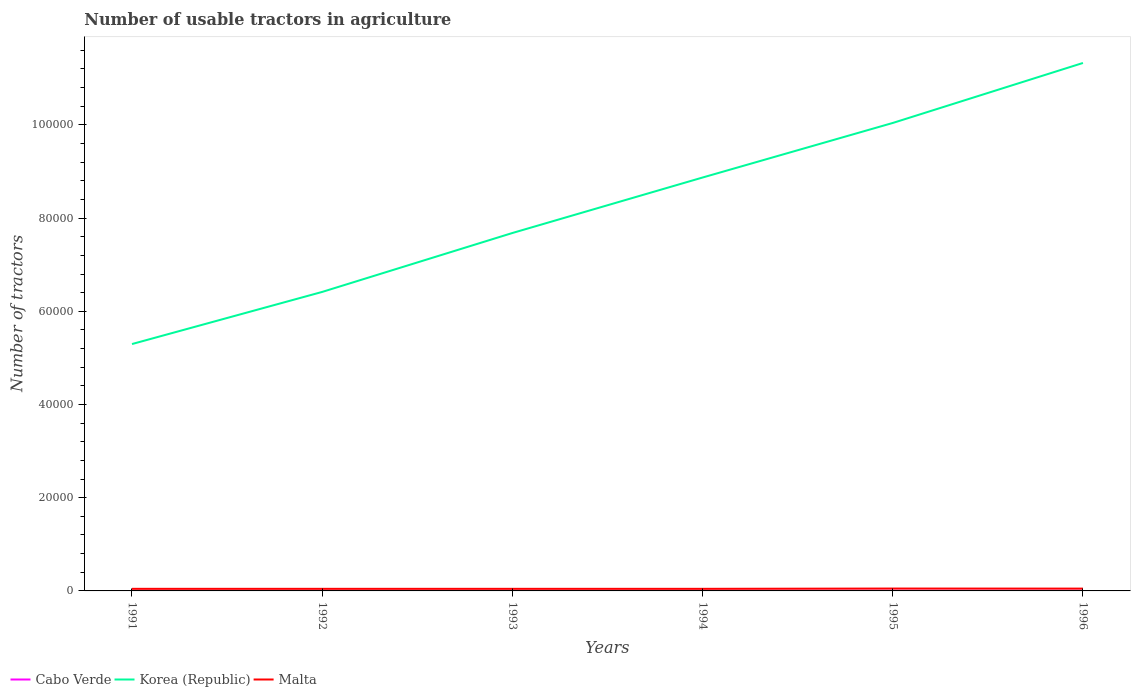How many different coloured lines are there?
Ensure brevity in your answer.  3. Does the line corresponding to Cabo Verde intersect with the line corresponding to Malta?
Provide a succinct answer. No. Across all years, what is the maximum number of usable tractors in agriculture in Korea (Republic)?
Offer a very short reply. 5.30e+04. In which year was the number of usable tractors in agriculture in Malta maximum?
Provide a succinct answer. 1991. What is the total number of usable tractors in agriculture in Korea (Republic) in the graph?
Ensure brevity in your answer.  -2.36e+04. What is the difference between the highest and the second highest number of usable tractors in agriculture in Korea (Republic)?
Offer a terse response. 6.03e+04. What is the difference between the highest and the lowest number of usable tractors in agriculture in Korea (Republic)?
Keep it short and to the point. 3. How many years are there in the graph?
Offer a terse response. 6. Are the values on the major ticks of Y-axis written in scientific E-notation?
Provide a short and direct response. No. Where does the legend appear in the graph?
Provide a succinct answer. Bottom left. What is the title of the graph?
Your response must be concise. Number of usable tractors in agriculture. Does "New Caledonia" appear as one of the legend labels in the graph?
Keep it short and to the point. No. What is the label or title of the X-axis?
Make the answer very short. Years. What is the label or title of the Y-axis?
Offer a terse response. Number of tractors. What is the Number of tractors of Korea (Republic) in 1991?
Offer a very short reply. 5.30e+04. What is the Number of tractors of Malta in 1991?
Give a very brief answer. 449. What is the Number of tractors in Korea (Republic) in 1992?
Offer a very short reply. 6.42e+04. What is the Number of tractors of Malta in 1992?
Your answer should be compact. 450. What is the Number of tractors in Korea (Republic) in 1993?
Provide a short and direct response. 7.68e+04. What is the Number of tractors of Malta in 1993?
Your answer should be compact. 450. What is the Number of tractors of Korea (Republic) in 1994?
Offer a very short reply. 8.87e+04. What is the Number of tractors in Malta in 1994?
Offer a terse response. 450. What is the Number of tractors in Korea (Republic) in 1995?
Provide a succinct answer. 1.00e+05. What is the Number of tractors of Malta in 1995?
Your answer should be very brief. 510. What is the Number of tractors of Cabo Verde in 1996?
Give a very brief answer. 41. What is the Number of tractors of Korea (Republic) in 1996?
Provide a short and direct response. 1.13e+05. What is the Number of tractors of Malta in 1996?
Offer a very short reply. 496. Across all years, what is the maximum Number of tractors of Korea (Republic)?
Provide a succinct answer. 1.13e+05. Across all years, what is the maximum Number of tractors of Malta?
Ensure brevity in your answer.  510. Across all years, what is the minimum Number of tractors in Korea (Republic)?
Give a very brief answer. 5.30e+04. Across all years, what is the minimum Number of tractors in Malta?
Your response must be concise. 449. What is the total Number of tractors in Cabo Verde in the graph?
Give a very brief answer. 216. What is the total Number of tractors in Korea (Republic) in the graph?
Offer a very short reply. 4.96e+05. What is the total Number of tractors in Malta in the graph?
Provide a short and direct response. 2805. What is the difference between the Number of tractors of Cabo Verde in 1991 and that in 1992?
Your answer should be very brief. -2. What is the difference between the Number of tractors of Korea (Republic) in 1991 and that in 1992?
Give a very brief answer. -1.12e+04. What is the difference between the Number of tractors of Malta in 1991 and that in 1992?
Offer a terse response. -1. What is the difference between the Number of tractors of Cabo Verde in 1991 and that in 1993?
Offer a very short reply. -4. What is the difference between the Number of tractors in Korea (Republic) in 1991 and that in 1993?
Provide a succinct answer. -2.38e+04. What is the difference between the Number of tractors of Korea (Republic) in 1991 and that in 1994?
Make the answer very short. -3.57e+04. What is the difference between the Number of tractors in Cabo Verde in 1991 and that in 1995?
Your answer should be very brief. -8. What is the difference between the Number of tractors in Korea (Republic) in 1991 and that in 1995?
Offer a very short reply. -4.74e+04. What is the difference between the Number of tractors in Malta in 1991 and that in 1995?
Keep it short and to the point. -61. What is the difference between the Number of tractors in Korea (Republic) in 1991 and that in 1996?
Keep it short and to the point. -6.03e+04. What is the difference between the Number of tractors in Malta in 1991 and that in 1996?
Your response must be concise. -47. What is the difference between the Number of tractors in Cabo Verde in 1992 and that in 1993?
Ensure brevity in your answer.  -2. What is the difference between the Number of tractors of Korea (Republic) in 1992 and that in 1993?
Offer a very short reply. -1.26e+04. What is the difference between the Number of tractors in Malta in 1992 and that in 1993?
Give a very brief answer. 0. What is the difference between the Number of tractors in Cabo Verde in 1992 and that in 1994?
Ensure brevity in your answer.  -4. What is the difference between the Number of tractors of Korea (Republic) in 1992 and that in 1994?
Offer a terse response. -2.45e+04. What is the difference between the Number of tractors in Korea (Republic) in 1992 and that in 1995?
Make the answer very short. -3.63e+04. What is the difference between the Number of tractors of Malta in 1992 and that in 1995?
Give a very brief answer. -60. What is the difference between the Number of tractors of Cabo Verde in 1992 and that in 1996?
Offer a very short reply. -8. What is the difference between the Number of tractors of Korea (Republic) in 1992 and that in 1996?
Your answer should be compact. -4.91e+04. What is the difference between the Number of tractors of Malta in 1992 and that in 1996?
Offer a very short reply. -46. What is the difference between the Number of tractors of Korea (Republic) in 1993 and that in 1994?
Your answer should be compact. -1.19e+04. What is the difference between the Number of tractors of Korea (Republic) in 1993 and that in 1995?
Make the answer very short. -2.36e+04. What is the difference between the Number of tractors of Malta in 1993 and that in 1995?
Keep it short and to the point. -60. What is the difference between the Number of tractors in Cabo Verde in 1993 and that in 1996?
Your answer should be compact. -6. What is the difference between the Number of tractors in Korea (Republic) in 1993 and that in 1996?
Ensure brevity in your answer.  -3.65e+04. What is the difference between the Number of tractors of Malta in 1993 and that in 1996?
Ensure brevity in your answer.  -46. What is the difference between the Number of tractors in Cabo Verde in 1994 and that in 1995?
Your answer should be very brief. -2. What is the difference between the Number of tractors of Korea (Republic) in 1994 and that in 1995?
Your response must be concise. -1.17e+04. What is the difference between the Number of tractors in Malta in 1994 and that in 1995?
Offer a very short reply. -60. What is the difference between the Number of tractors in Korea (Republic) in 1994 and that in 1996?
Give a very brief answer. -2.46e+04. What is the difference between the Number of tractors of Malta in 1994 and that in 1996?
Make the answer very short. -46. What is the difference between the Number of tractors in Cabo Verde in 1995 and that in 1996?
Offer a terse response. -2. What is the difference between the Number of tractors of Korea (Republic) in 1995 and that in 1996?
Your answer should be very brief. -1.29e+04. What is the difference between the Number of tractors in Malta in 1995 and that in 1996?
Make the answer very short. 14. What is the difference between the Number of tractors in Cabo Verde in 1991 and the Number of tractors in Korea (Republic) in 1992?
Your answer should be very brief. -6.41e+04. What is the difference between the Number of tractors of Cabo Verde in 1991 and the Number of tractors of Malta in 1992?
Provide a short and direct response. -419. What is the difference between the Number of tractors of Korea (Republic) in 1991 and the Number of tractors of Malta in 1992?
Ensure brevity in your answer.  5.25e+04. What is the difference between the Number of tractors of Cabo Verde in 1991 and the Number of tractors of Korea (Republic) in 1993?
Offer a very short reply. -7.68e+04. What is the difference between the Number of tractors in Cabo Verde in 1991 and the Number of tractors in Malta in 1993?
Offer a very short reply. -419. What is the difference between the Number of tractors of Korea (Republic) in 1991 and the Number of tractors of Malta in 1993?
Keep it short and to the point. 5.25e+04. What is the difference between the Number of tractors of Cabo Verde in 1991 and the Number of tractors of Korea (Republic) in 1994?
Make the answer very short. -8.87e+04. What is the difference between the Number of tractors in Cabo Verde in 1991 and the Number of tractors in Malta in 1994?
Your answer should be very brief. -419. What is the difference between the Number of tractors of Korea (Republic) in 1991 and the Number of tractors of Malta in 1994?
Offer a terse response. 5.25e+04. What is the difference between the Number of tractors of Cabo Verde in 1991 and the Number of tractors of Korea (Republic) in 1995?
Provide a succinct answer. -1.00e+05. What is the difference between the Number of tractors of Cabo Verde in 1991 and the Number of tractors of Malta in 1995?
Provide a succinct answer. -479. What is the difference between the Number of tractors of Korea (Republic) in 1991 and the Number of tractors of Malta in 1995?
Ensure brevity in your answer.  5.25e+04. What is the difference between the Number of tractors of Cabo Verde in 1991 and the Number of tractors of Korea (Republic) in 1996?
Provide a succinct answer. -1.13e+05. What is the difference between the Number of tractors of Cabo Verde in 1991 and the Number of tractors of Malta in 1996?
Provide a short and direct response. -465. What is the difference between the Number of tractors in Korea (Republic) in 1991 and the Number of tractors in Malta in 1996?
Ensure brevity in your answer.  5.25e+04. What is the difference between the Number of tractors of Cabo Verde in 1992 and the Number of tractors of Korea (Republic) in 1993?
Provide a short and direct response. -7.68e+04. What is the difference between the Number of tractors in Cabo Verde in 1992 and the Number of tractors in Malta in 1993?
Give a very brief answer. -417. What is the difference between the Number of tractors of Korea (Republic) in 1992 and the Number of tractors of Malta in 1993?
Offer a very short reply. 6.37e+04. What is the difference between the Number of tractors of Cabo Verde in 1992 and the Number of tractors of Korea (Republic) in 1994?
Your answer should be compact. -8.87e+04. What is the difference between the Number of tractors of Cabo Verde in 1992 and the Number of tractors of Malta in 1994?
Provide a succinct answer. -417. What is the difference between the Number of tractors of Korea (Republic) in 1992 and the Number of tractors of Malta in 1994?
Make the answer very short. 6.37e+04. What is the difference between the Number of tractors of Cabo Verde in 1992 and the Number of tractors of Korea (Republic) in 1995?
Keep it short and to the point. -1.00e+05. What is the difference between the Number of tractors in Cabo Verde in 1992 and the Number of tractors in Malta in 1995?
Ensure brevity in your answer.  -477. What is the difference between the Number of tractors in Korea (Republic) in 1992 and the Number of tractors in Malta in 1995?
Give a very brief answer. 6.36e+04. What is the difference between the Number of tractors in Cabo Verde in 1992 and the Number of tractors in Korea (Republic) in 1996?
Offer a terse response. -1.13e+05. What is the difference between the Number of tractors in Cabo Verde in 1992 and the Number of tractors in Malta in 1996?
Give a very brief answer. -463. What is the difference between the Number of tractors of Korea (Republic) in 1992 and the Number of tractors of Malta in 1996?
Ensure brevity in your answer.  6.37e+04. What is the difference between the Number of tractors in Cabo Verde in 1993 and the Number of tractors in Korea (Republic) in 1994?
Provide a succinct answer. -8.87e+04. What is the difference between the Number of tractors in Cabo Verde in 1993 and the Number of tractors in Malta in 1994?
Offer a terse response. -415. What is the difference between the Number of tractors in Korea (Republic) in 1993 and the Number of tractors in Malta in 1994?
Offer a very short reply. 7.64e+04. What is the difference between the Number of tractors in Cabo Verde in 1993 and the Number of tractors in Korea (Republic) in 1995?
Your answer should be compact. -1.00e+05. What is the difference between the Number of tractors of Cabo Verde in 1993 and the Number of tractors of Malta in 1995?
Make the answer very short. -475. What is the difference between the Number of tractors in Korea (Republic) in 1993 and the Number of tractors in Malta in 1995?
Your response must be concise. 7.63e+04. What is the difference between the Number of tractors of Cabo Verde in 1993 and the Number of tractors of Korea (Republic) in 1996?
Provide a succinct answer. -1.13e+05. What is the difference between the Number of tractors of Cabo Verde in 1993 and the Number of tractors of Malta in 1996?
Offer a very short reply. -461. What is the difference between the Number of tractors of Korea (Republic) in 1993 and the Number of tractors of Malta in 1996?
Provide a short and direct response. 7.63e+04. What is the difference between the Number of tractors in Cabo Verde in 1994 and the Number of tractors in Korea (Republic) in 1995?
Your response must be concise. -1.00e+05. What is the difference between the Number of tractors of Cabo Verde in 1994 and the Number of tractors of Malta in 1995?
Your response must be concise. -473. What is the difference between the Number of tractors in Korea (Republic) in 1994 and the Number of tractors in Malta in 1995?
Make the answer very short. 8.82e+04. What is the difference between the Number of tractors of Cabo Verde in 1994 and the Number of tractors of Korea (Republic) in 1996?
Give a very brief answer. -1.13e+05. What is the difference between the Number of tractors of Cabo Verde in 1994 and the Number of tractors of Malta in 1996?
Keep it short and to the point. -459. What is the difference between the Number of tractors in Korea (Republic) in 1994 and the Number of tractors in Malta in 1996?
Ensure brevity in your answer.  8.82e+04. What is the difference between the Number of tractors of Cabo Verde in 1995 and the Number of tractors of Korea (Republic) in 1996?
Keep it short and to the point. -1.13e+05. What is the difference between the Number of tractors in Cabo Verde in 1995 and the Number of tractors in Malta in 1996?
Provide a short and direct response. -457. What is the difference between the Number of tractors in Korea (Republic) in 1995 and the Number of tractors in Malta in 1996?
Provide a succinct answer. 9.99e+04. What is the average Number of tractors of Korea (Republic) per year?
Provide a short and direct response. 8.27e+04. What is the average Number of tractors of Malta per year?
Provide a succinct answer. 467.5. In the year 1991, what is the difference between the Number of tractors of Cabo Verde and Number of tractors of Korea (Republic)?
Ensure brevity in your answer.  -5.29e+04. In the year 1991, what is the difference between the Number of tractors of Cabo Verde and Number of tractors of Malta?
Provide a short and direct response. -418. In the year 1991, what is the difference between the Number of tractors of Korea (Republic) and Number of tractors of Malta?
Your answer should be compact. 5.25e+04. In the year 1992, what is the difference between the Number of tractors of Cabo Verde and Number of tractors of Korea (Republic)?
Keep it short and to the point. -6.41e+04. In the year 1992, what is the difference between the Number of tractors in Cabo Verde and Number of tractors in Malta?
Ensure brevity in your answer.  -417. In the year 1992, what is the difference between the Number of tractors in Korea (Republic) and Number of tractors in Malta?
Your answer should be compact. 6.37e+04. In the year 1993, what is the difference between the Number of tractors in Cabo Verde and Number of tractors in Korea (Republic)?
Provide a succinct answer. -7.68e+04. In the year 1993, what is the difference between the Number of tractors of Cabo Verde and Number of tractors of Malta?
Provide a succinct answer. -415. In the year 1993, what is the difference between the Number of tractors of Korea (Republic) and Number of tractors of Malta?
Keep it short and to the point. 7.64e+04. In the year 1994, what is the difference between the Number of tractors of Cabo Verde and Number of tractors of Korea (Republic)?
Your response must be concise. -8.87e+04. In the year 1994, what is the difference between the Number of tractors in Cabo Verde and Number of tractors in Malta?
Keep it short and to the point. -413. In the year 1994, what is the difference between the Number of tractors in Korea (Republic) and Number of tractors in Malta?
Give a very brief answer. 8.83e+04. In the year 1995, what is the difference between the Number of tractors of Cabo Verde and Number of tractors of Korea (Republic)?
Keep it short and to the point. -1.00e+05. In the year 1995, what is the difference between the Number of tractors in Cabo Verde and Number of tractors in Malta?
Offer a very short reply. -471. In the year 1995, what is the difference between the Number of tractors in Korea (Republic) and Number of tractors in Malta?
Keep it short and to the point. 9.99e+04. In the year 1996, what is the difference between the Number of tractors in Cabo Verde and Number of tractors in Korea (Republic)?
Provide a short and direct response. -1.13e+05. In the year 1996, what is the difference between the Number of tractors of Cabo Verde and Number of tractors of Malta?
Ensure brevity in your answer.  -455. In the year 1996, what is the difference between the Number of tractors of Korea (Republic) and Number of tractors of Malta?
Provide a short and direct response. 1.13e+05. What is the ratio of the Number of tractors in Cabo Verde in 1991 to that in 1992?
Offer a terse response. 0.94. What is the ratio of the Number of tractors of Korea (Republic) in 1991 to that in 1992?
Give a very brief answer. 0.83. What is the ratio of the Number of tractors of Malta in 1991 to that in 1992?
Ensure brevity in your answer.  1. What is the ratio of the Number of tractors of Cabo Verde in 1991 to that in 1993?
Ensure brevity in your answer.  0.89. What is the ratio of the Number of tractors in Korea (Republic) in 1991 to that in 1993?
Offer a terse response. 0.69. What is the ratio of the Number of tractors in Cabo Verde in 1991 to that in 1994?
Your answer should be compact. 0.84. What is the ratio of the Number of tractors in Korea (Republic) in 1991 to that in 1994?
Provide a succinct answer. 0.6. What is the ratio of the Number of tractors in Malta in 1991 to that in 1994?
Your answer should be compact. 1. What is the ratio of the Number of tractors in Cabo Verde in 1991 to that in 1995?
Keep it short and to the point. 0.79. What is the ratio of the Number of tractors in Korea (Republic) in 1991 to that in 1995?
Provide a short and direct response. 0.53. What is the ratio of the Number of tractors in Malta in 1991 to that in 1995?
Offer a terse response. 0.88. What is the ratio of the Number of tractors in Cabo Verde in 1991 to that in 1996?
Your answer should be compact. 0.76. What is the ratio of the Number of tractors in Korea (Republic) in 1991 to that in 1996?
Your answer should be very brief. 0.47. What is the ratio of the Number of tractors in Malta in 1991 to that in 1996?
Make the answer very short. 0.91. What is the ratio of the Number of tractors in Cabo Verde in 1992 to that in 1993?
Keep it short and to the point. 0.94. What is the ratio of the Number of tractors of Korea (Republic) in 1992 to that in 1993?
Your answer should be very brief. 0.84. What is the ratio of the Number of tractors of Malta in 1992 to that in 1993?
Provide a short and direct response. 1. What is the ratio of the Number of tractors in Cabo Verde in 1992 to that in 1994?
Give a very brief answer. 0.89. What is the ratio of the Number of tractors in Korea (Republic) in 1992 to that in 1994?
Offer a terse response. 0.72. What is the ratio of the Number of tractors of Malta in 1992 to that in 1994?
Make the answer very short. 1. What is the ratio of the Number of tractors of Cabo Verde in 1992 to that in 1995?
Provide a short and direct response. 0.85. What is the ratio of the Number of tractors of Korea (Republic) in 1992 to that in 1995?
Give a very brief answer. 0.64. What is the ratio of the Number of tractors in Malta in 1992 to that in 1995?
Offer a very short reply. 0.88. What is the ratio of the Number of tractors in Cabo Verde in 1992 to that in 1996?
Offer a very short reply. 0.8. What is the ratio of the Number of tractors in Korea (Republic) in 1992 to that in 1996?
Offer a very short reply. 0.57. What is the ratio of the Number of tractors in Malta in 1992 to that in 1996?
Offer a very short reply. 0.91. What is the ratio of the Number of tractors of Cabo Verde in 1993 to that in 1994?
Offer a terse response. 0.95. What is the ratio of the Number of tractors of Korea (Republic) in 1993 to that in 1994?
Your answer should be very brief. 0.87. What is the ratio of the Number of tractors of Cabo Verde in 1993 to that in 1995?
Make the answer very short. 0.9. What is the ratio of the Number of tractors of Korea (Republic) in 1993 to that in 1995?
Provide a short and direct response. 0.76. What is the ratio of the Number of tractors in Malta in 1993 to that in 1995?
Your answer should be compact. 0.88. What is the ratio of the Number of tractors of Cabo Verde in 1993 to that in 1996?
Ensure brevity in your answer.  0.85. What is the ratio of the Number of tractors in Korea (Republic) in 1993 to that in 1996?
Offer a terse response. 0.68. What is the ratio of the Number of tractors in Malta in 1993 to that in 1996?
Give a very brief answer. 0.91. What is the ratio of the Number of tractors of Cabo Verde in 1994 to that in 1995?
Provide a short and direct response. 0.95. What is the ratio of the Number of tractors of Korea (Republic) in 1994 to that in 1995?
Offer a terse response. 0.88. What is the ratio of the Number of tractors of Malta in 1994 to that in 1995?
Keep it short and to the point. 0.88. What is the ratio of the Number of tractors of Cabo Verde in 1994 to that in 1996?
Offer a terse response. 0.9. What is the ratio of the Number of tractors in Korea (Republic) in 1994 to that in 1996?
Give a very brief answer. 0.78. What is the ratio of the Number of tractors of Malta in 1994 to that in 1996?
Offer a very short reply. 0.91. What is the ratio of the Number of tractors in Cabo Verde in 1995 to that in 1996?
Your response must be concise. 0.95. What is the ratio of the Number of tractors of Korea (Republic) in 1995 to that in 1996?
Provide a short and direct response. 0.89. What is the ratio of the Number of tractors of Malta in 1995 to that in 1996?
Offer a very short reply. 1.03. What is the difference between the highest and the second highest Number of tractors of Korea (Republic)?
Offer a terse response. 1.29e+04. What is the difference between the highest and the lowest Number of tractors of Cabo Verde?
Offer a very short reply. 10. What is the difference between the highest and the lowest Number of tractors of Korea (Republic)?
Keep it short and to the point. 6.03e+04. What is the difference between the highest and the lowest Number of tractors of Malta?
Your response must be concise. 61. 